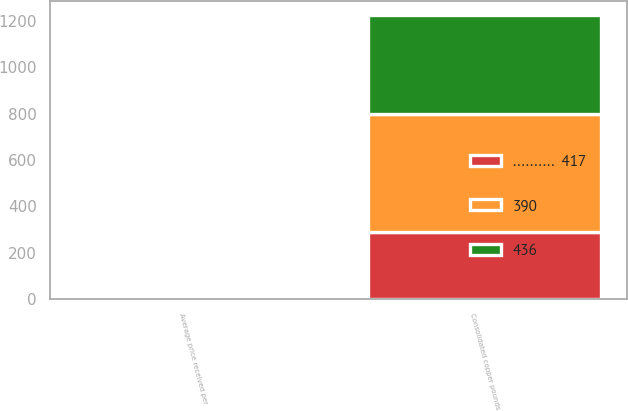Convert chart. <chart><loc_0><loc_0><loc_500><loc_500><stacked_bar_chart><ecel><fcel>Consolidated copper pounds<fcel>Average price received per<nl><fcel>390<fcel>507<fcel>2.6<nl><fcel>..........  417<fcel>290<fcel>2.59<nl><fcel>436<fcel>428<fcel>2.86<nl></chart> 